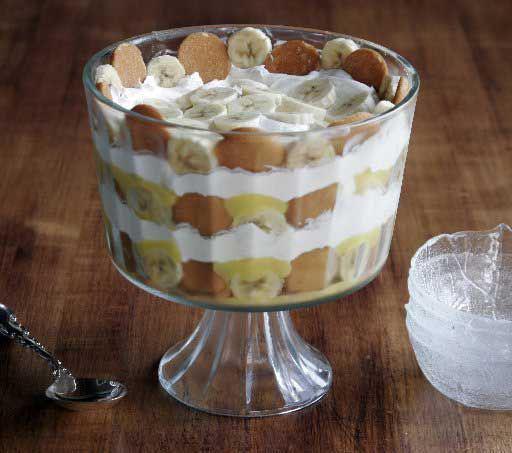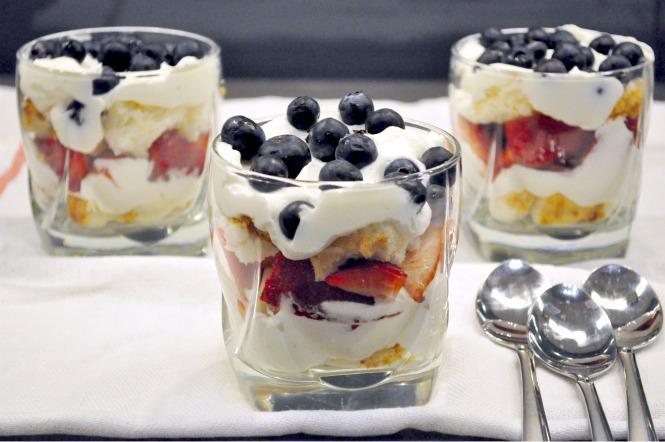The first image is the image on the left, the second image is the image on the right. For the images shown, is this caption "An image shows a cream-layered dessert in a clear footed glass." true? Answer yes or no. Yes. The first image is the image on the left, the second image is the image on the right. Given the left and right images, does the statement "There are three silver spoons next to the desserts in one of the images." hold true? Answer yes or no. Yes. 